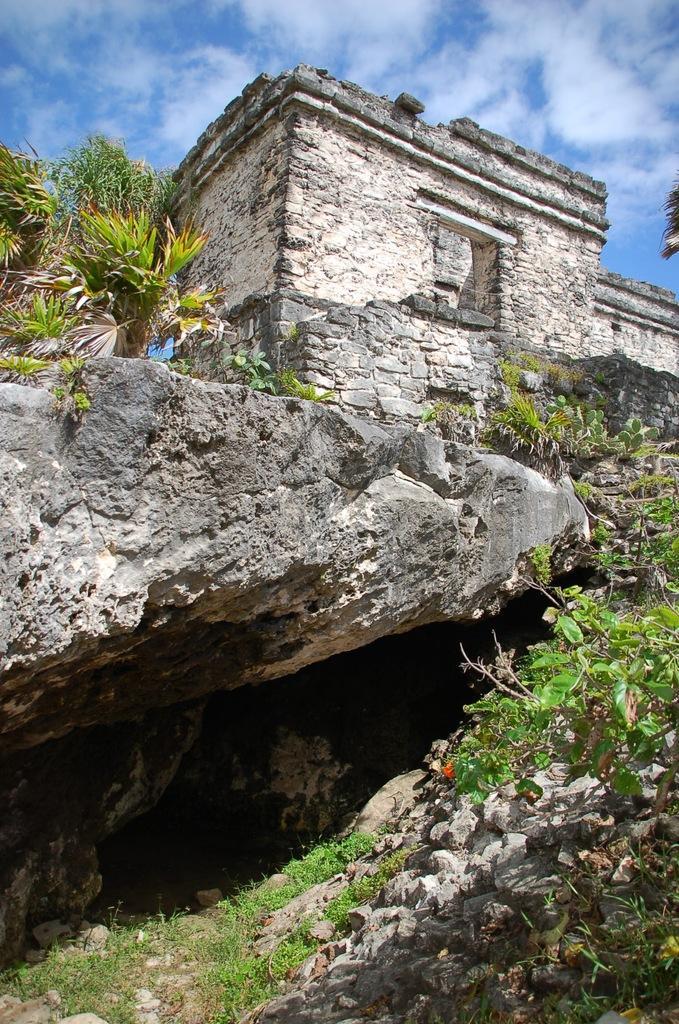How would you summarize this image in a sentence or two? In this image we can see a building on the rock and there are few plants near the building and there is the sky with clouds in the background. 